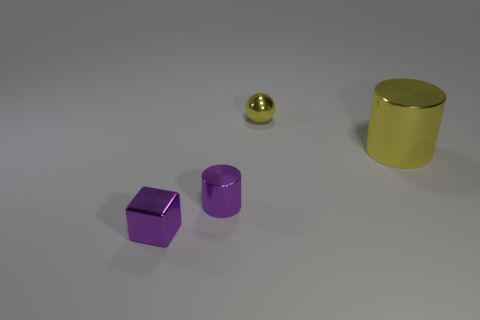Add 1 small brown blocks. How many objects exist? 5 Subtract all cubes. How many objects are left? 3 Subtract all small metallic spheres. Subtract all purple shiny blocks. How many objects are left? 2 Add 4 purple cylinders. How many purple cylinders are left? 5 Add 4 large metal cylinders. How many large metal cylinders exist? 5 Subtract 0 purple spheres. How many objects are left? 4 Subtract all red cylinders. Subtract all cyan cubes. How many cylinders are left? 2 